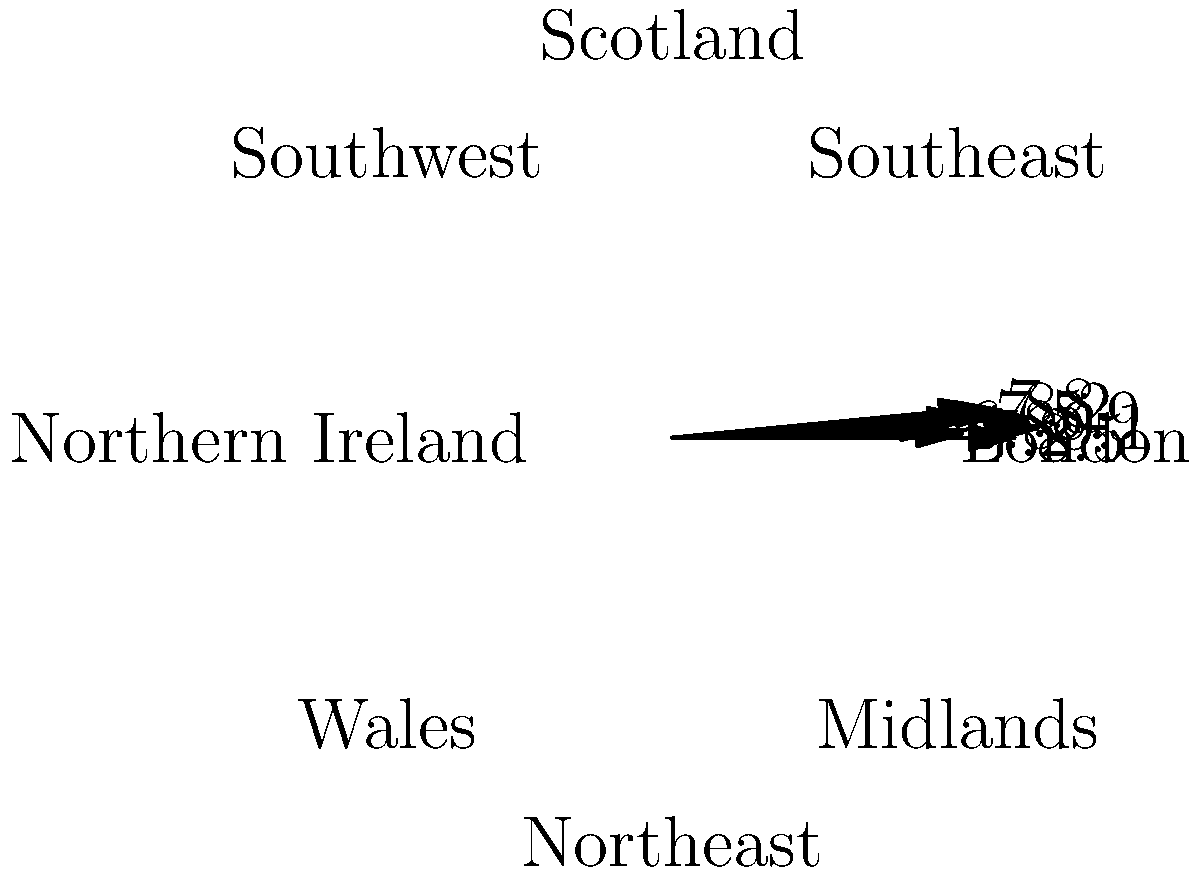Based on the polar rose diagram showing insurance policy renewal rates (in percentages) across different regions in the UK, which region has the highest renewal rate, and what is the difference between the highest and lowest rates? To answer this question, we need to follow these steps:

1. Identify the highest renewal rate:
   Examining the diagram, we can see that Scotland has the highest value at 9.1%.

2. Identify the lowest renewal rate:
   The Southwest region has the lowest value at 6.8%.

3. Calculate the difference between the highest and lowest rates:
   $9.1\% - 6.8\% = 2.3\%$

Therefore, Scotland has the highest renewal rate, and the difference between the highest (Scotland) and lowest (Southwest) rates is 2.3 percentage points.
Answer: Scotland; 2.3 percentage points 